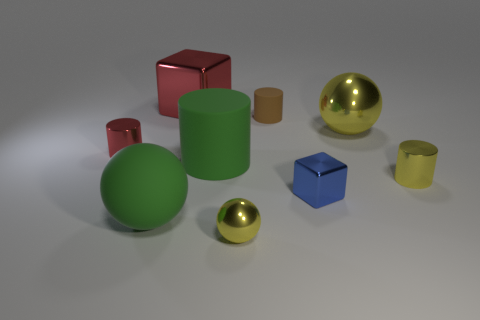Subtract all blue cylinders. Subtract all brown cubes. How many cylinders are left? 4 Add 1 big brown shiny cubes. How many objects exist? 10 Subtract all cylinders. How many objects are left? 5 Subtract 0 gray cylinders. How many objects are left? 9 Subtract all small yellow cylinders. Subtract all small metal cylinders. How many objects are left? 6 Add 1 yellow things. How many yellow things are left? 4 Add 2 large gray objects. How many large gray objects exist? 2 